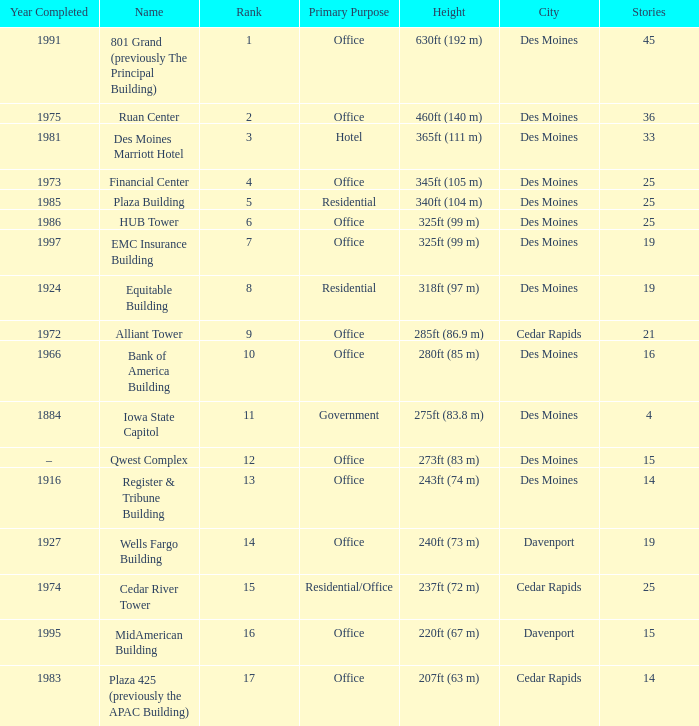What is the total stories that rank number 10? 1.0. 